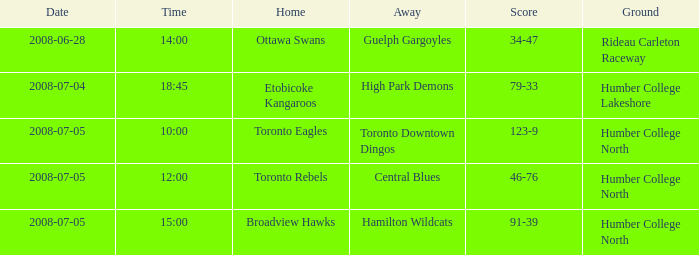What is the Ground with an Away that is central blues? Humber College North. 